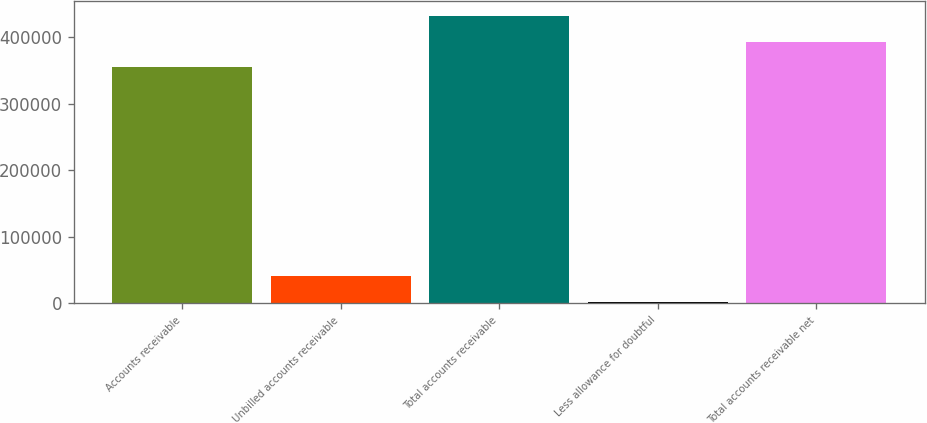Convert chart. <chart><loc_0><loc_0><loc_500><loc_500><bar_chart><fcel>Accounts receivable<fcel>Unbilled accounts receivable<fcel>Total accounts receivable<fcel>Less allowance for doubtful<fcel>Total accounts receivable net<nl><fcel>354688<fcel>41130.4<fcel>431827<fcel>2561<fcel>393257<nl></chart> 